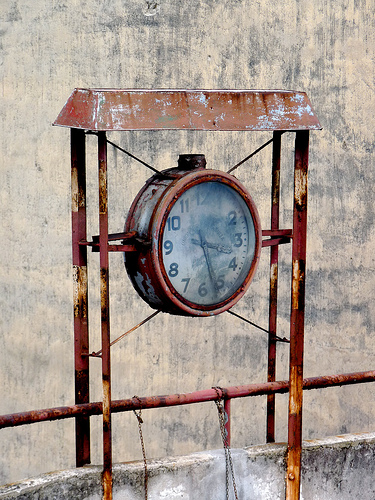Please provide the bounding box coordinate of the region this sentence describes: dirt on the front of clock. [0.47, 0.40, 0.61, 0.58] - These coordinates more accurately encase the area of the dirt on the weathered, rusted clock face, enhancing the focus on the described feature. 